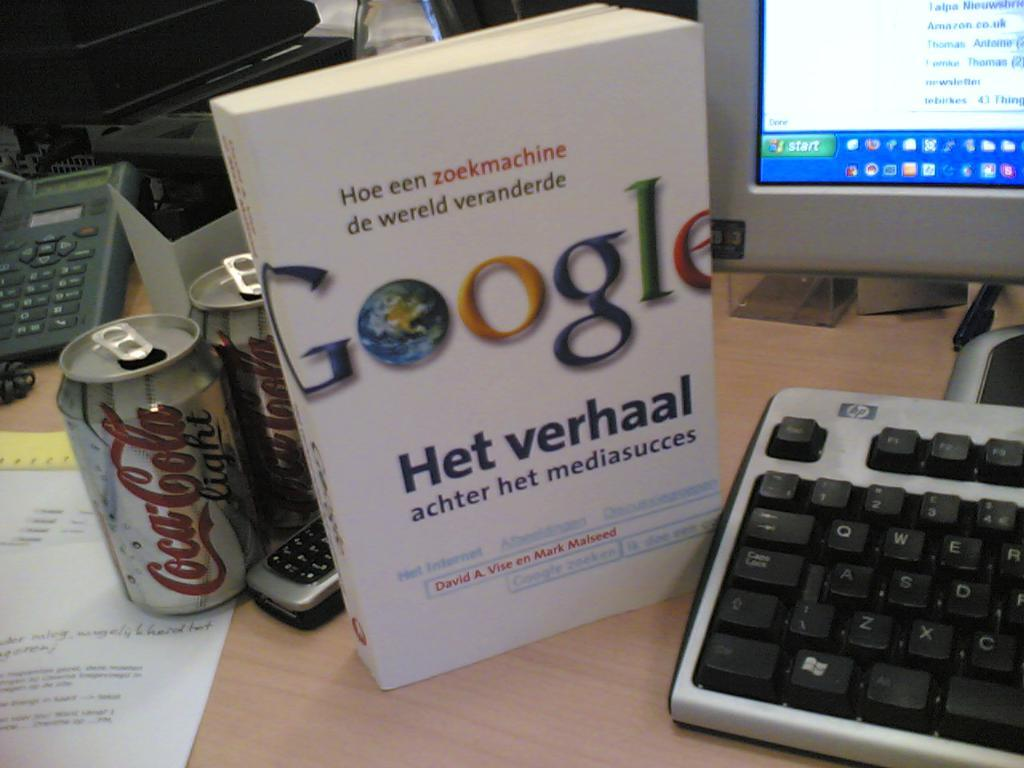<image>
Share a concise interpretation of the image provided. In between a computer monitor and a can of Diet Coke is a white box labeled Google Het verhaal. 